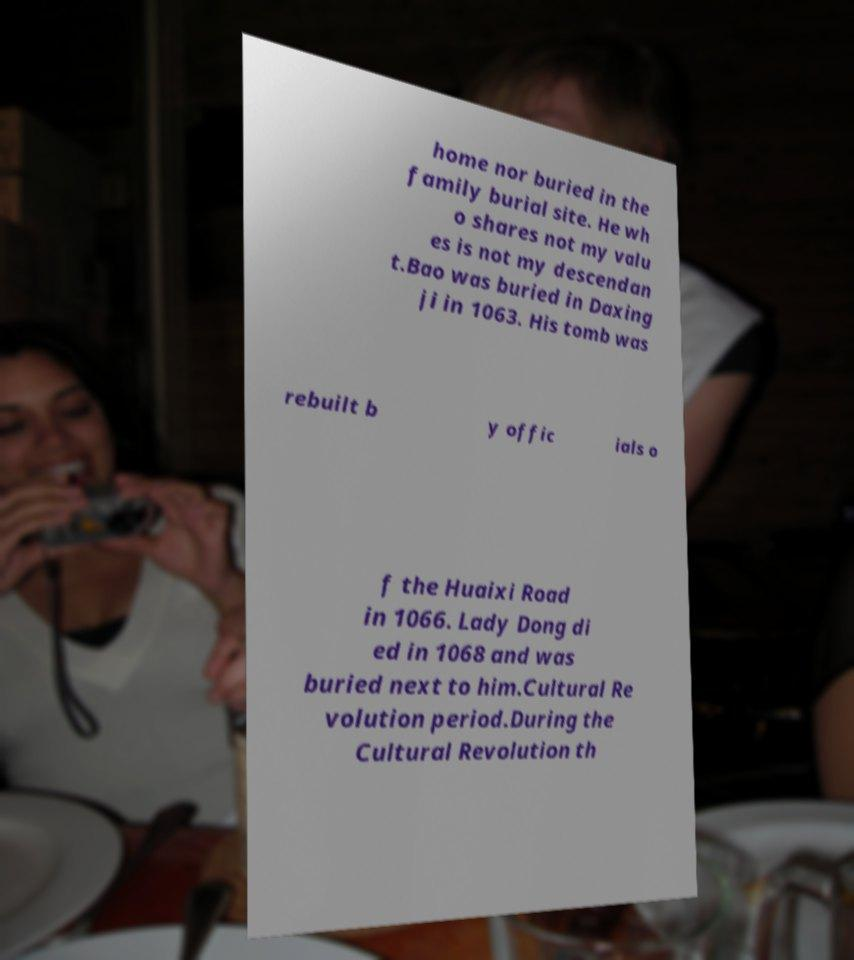Could you extract and type out the text from this image? home nor buried in the family burial site. He wh o shares not my valu es is not my descendan t.Bao was buried in Daxing ji in 1063. His tomb was rebuilt b y offic ials o f the Huaixi Road in 1066. Lady Dong di ed in 1068 and was buried next to him.Cultural Re volution period.During the Cultural Revolution th 